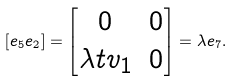<formula> <loc_0><loc_0><loc_500><loc_500>[ e _ { 5 } e _ { 2 } ] = \begin{bmatrix} 0 & 0 \\ \lambda t v _ { 1 } & 0 \\ \end{bmatrix} = \lambda e _ { 7 } .</formula> 